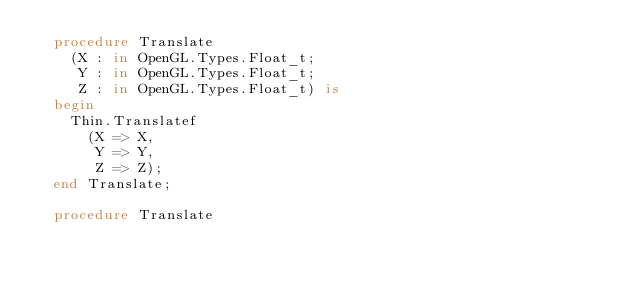<code> <loc_0><loc_0><loc_500><loc_500><_Ada_>  procedure Translate
    (X : in OpenGL.Types.Float_t;
     Y : in OpenGL.Types.Float_t;
     Z : in OpenGL.Types.Float_t) is
  begin
    Thin.Translatef
      (X => X,
       Y => Y,
       Z => Z);
  end Translate;

  procedure Translate</code> 